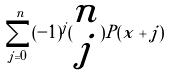<formula> <loc_0><loc_0><loc_500><loc_500>\sum _ { j = 0 } ^ { n } ( - 1 ) ^ { j } ( \begin{matrix} n \\ j \end{matrix} ) P ( x + j )</formula> 